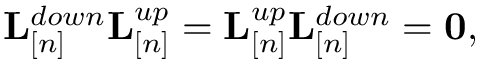Convert formula to latex. <formula><loc_0><loc_0><loc_500><loc_500>\begin{array} { r } { { L } _ { [ n ] } ^ { d o w n } { L } _ { [ n ] } ^ { u p } = { L } _ { [ n ] } ^ { u p } { L } _ { [ n ] } ^ { d o w n } = { 0 } , } \end{array}</formula> 